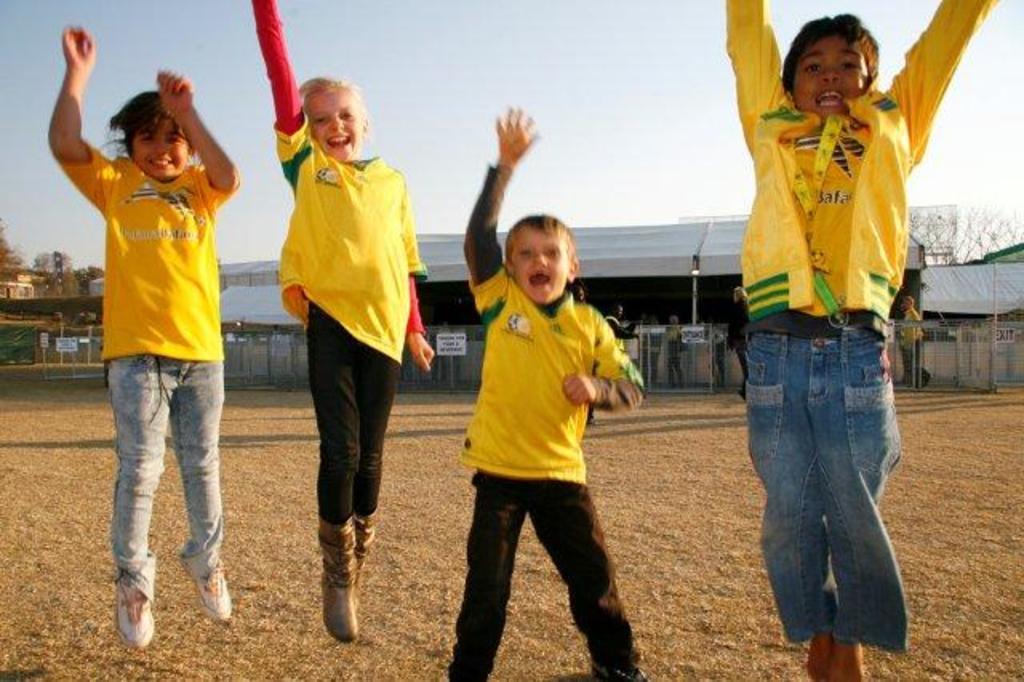Describe this image in one or two sentences. In this image we can see four children. In the back there are railings and there is a shed. In the background there are trees and sky. Also there are few people. 